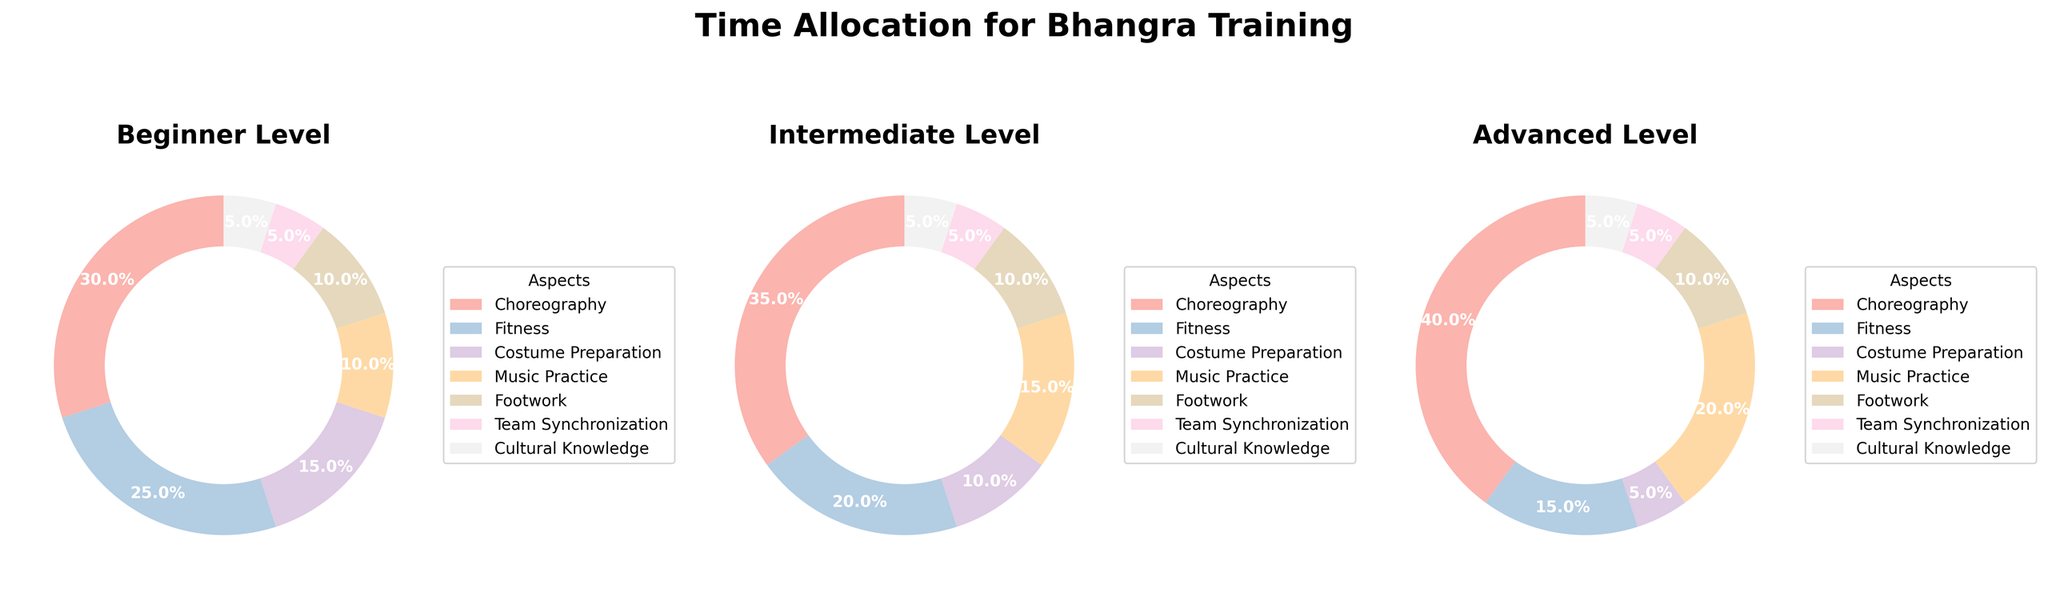What percentage of time is allocated to choreography at the advanced level? By inspecting the pie chart for the advanced level, look at the segment labeled 'Choreography' and find the percentage displayed.
Answer: 40% At the intermediate level, which aspect has the highest time allocation? By examining the pie chart for the intermediate level, identify the largest segment, and check the label.
Answer: Choreography How does the time allocated to fitness change from beginner to advanced levels? Compare the fitness percentages from the beginner, intermediate, and advanced pie charts. For beginners, it's 25%; for intermediate, it's 20%; and for advanced, it's 15%. This shows a decrease in fitness time allocation as the level progresses.
Answer: Decreases Combine the time allocated to music practice and footwork at the beginner level. What percentage do they add up to? Locate the segments for music practice (10%) and footwork (10%) in the beginner level's pie chart and sum them up. 10% + 10% = 20%
Answer: 20% Is there any aspect with the same time allocation across all levels? If yes, which one(s)? Look at all three pie charts and find segments with identical percentages across the beginner, intermediate, and advanced levels. Team Synchronization and Cultural Knowledge both have 5% across all levels.
Answer: Team Synchronization, Cultural Knowledge Which aspect decreases the most in time allocation from beginner to advanced level? Identify the aspect with the highest time allocation at the beginner level and then see how much it decreases at the advanced level. Choreography increased, Fitness decreased from 25% to 15%, a total of 10%.
Answer: Fitness What is the percentage difference in time allocated to costume preparation between beginner and advanced levels? Check the costume preparation percentages for both beginner and advanced levels (15% and 5%, respectively) and calculate the difference. 15% - 5% = 10%
Answer: 10% Which level allocates the least percentage of time to footwork? Examine the footwork segment in each of the three pie charts and note the percentages. All levels allocate 10% to footwork, so there is no difference.
Answer: All levels allocate the same time How does the time allocated to music practice at the intermediate level compare to the advanced level? Check the music practice segments in the intermediate (15%) and advanced (20%) pie charts and compare them. 20% is greater than 15%.
Answer: Advanced level allocates more time Identify the aspect with the second-highest time allocation at the beginner level. By examining the pie chart for the beginner level, identify the second-largest segment after Choreography (30%). Fitness is the second highest with 25%.
Answer: Fitness 